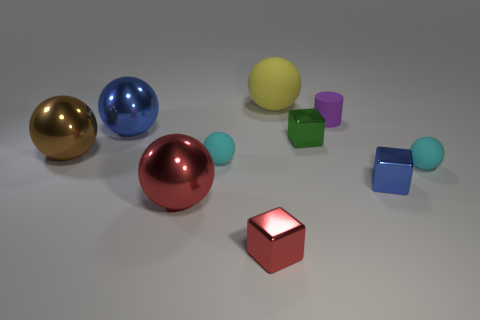What number of balls are made of the same material as the yellow object?
Give a very brief answer. 2. What is the material of the large blue sphere?
Your answer should be very brief. Metal. The big object to the left of the blue thing that is behind the big brown metal thing is what shape?
Provide a short and direct response. Sphere. There is a matte thing that is behind the tiny purple rubber thing; what shape is it?
Your response must be concise. Sphere. How many blocks have the same color as the small matte cylinder?
Your answer should be compact. 0. The rubber cylinder has what color?
Offer a terse response. Purple. There is a shiny cube that is in front of the red shiny sphere; how many spheres are to the right of it?
Provide a succinct answer. 2. There is a blue ball; does it have the same size as the blue object that is right of the large blue thing?
Your answer should be compact. No. Does the blue shiny cube have the same size as the brown object?
Your answer should be compact. No. Are there any rubber objects that have the same size as the purple cylinder?
Offer a very short reply. Yes. 